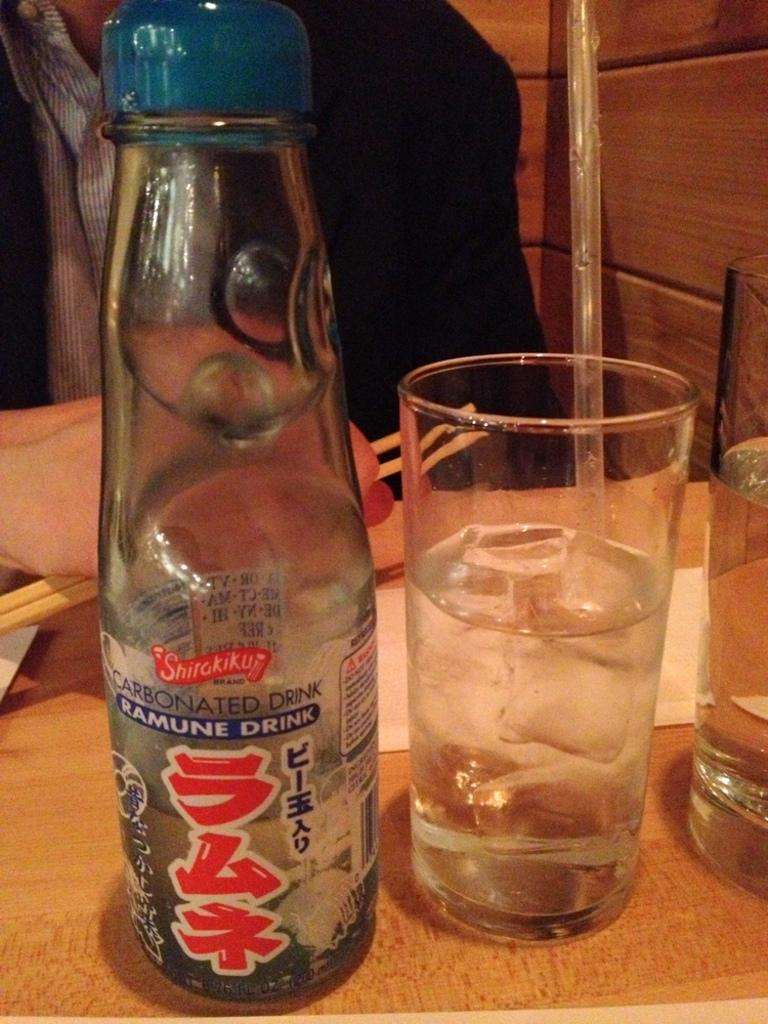What objects are on the table in the image? There are glasses, a bottle, and paper on the table in the image. What is the person in the image wearing? The person is wearing a suit. What is the person holding in the image? The person is holding chopsticks. What verse is the person reciting in the image? There is no indication in the image that the person is reciting a verse. 